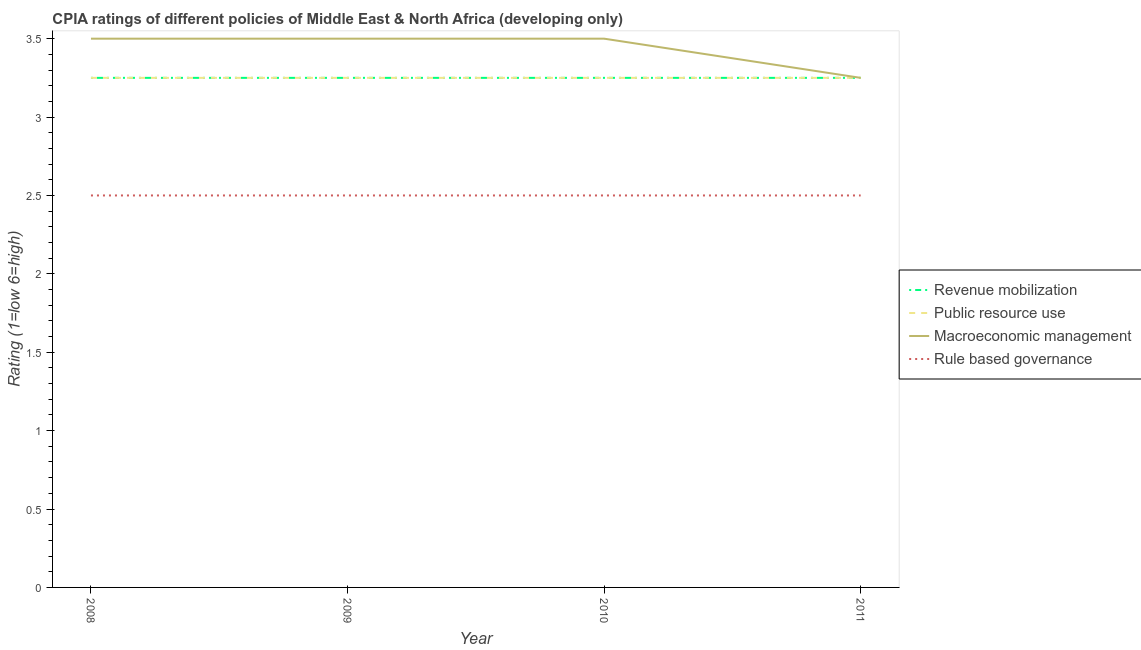What is the cpia rating of public resource use in 2010?
Your answer should be very brief. 3.25. Across all years, what is the maximum cpia rating of macroeconomic management?
Give a very brief answer. 3.5. In which year was the cpia rating of macroeconomic management minimum?
Offer a very short reply. 2011. What is the total cpia rating of public resource use in the graph?
Your response must be concise. 13. What is the difference between the cpia rating of public resource use in 2008 and that in 2009?
Give a very brief answer. 0. What is the average cpia rating of public resource use per year?
Keep it short and to the point. 3.25. In how many years, is the cpia rating of revenue mobilization greater than 1.4?
Keep it short and to the point. 4. What is the ratio of the cpia rating of public resource use in 2010 to that in 2011?
Keep it short and to the point. 1. Is the cpia rating of revenue mobilization in 2010 less than that in 2011?
Give a very brief answer. No. Is the difference between the cpia rating of rule based governance in 2008 and 2011 greater than the difference between the cpia rating of revenue mobilization in 2008 and 2011?
Keep it short and to the point. No. In how many years, is the cpia rating of revenue mobilization greater than the average cpia rating of revenue mobilization taken over all years?
Make the answer very short. 0. Is the cpia rating of rule based governance strictly greater than the cpia rating of revenue mobilization over the years?
Make the answer very short. No. How many lines are there?
Keep it short and to the point. 4. Does the graph contain grids?
Your response must be concise. No. Where does the legend appear in the graph?
Ensure brevity in your answer.  Center right. What is the title of the graph?
Your answer should be very brief. CPIA ratings of different policies of Middle East & North Africa (developing only). Does "UNAIDS" appear as one of the legend labels in the graph?
Offer a terse response. No. What is the Rating (1=low 6=high) of Revenue mobilization in 2008?
Keep it short and to the point. 3.25. What is the Rating (1=low 6=high) in Revenue mobilization in 2009?
Make the answer very short. 3.25. What is the Rating (1=low 6=high) in Public resource use in 2009?
Provide a succinct answer. 3.25. What is the Rating (1=low 6=high) in Macroeconomic management in 2009?
Provide a short and direct response. 3.5. What is the Rating (1=low 6=high) in Rule based governance in 2009?
Your answer should be compact. 2.5. What is the Rating (1=low 6=high) of Public resource use in 2010?
Your answer should be very brief. 3.25. What is the Rating (1=low 6=high) of Macroeconomic management in 2010?
Your answer should be very brief. 3.5. What is the Rating (1=low 6=high) in Rule based governance in 2010?
Provide a short and direct response. 2.5. What is the Rating (1=low 6=high) in Revenue mobilization in 2011?
Provide a short and direct response. 3.25. What is the Rating (1=low 6=high) in Macroeconomic management in 2011?
Offer a very short reply. 3.25. Across all years, what is the maximum Rating (1=low 6=high) in Macroeconomic management?
Offer a terse response. 3.5. Across all years, what is the maximum Rating (1=low 6=high) of Rule based governance?
Offer a very short reply. 2.5. Across all years, what is the minimum Rating (1=low 6=high) of Revenue mobilization?
Offer a terse response. 3.25. Across all years, what is the minimum Rating (1=low 6=high) of Macroeconomic management?
Offer a very short reply. 3.25. Across all years, what is the minimum Rating (1=low 6=high) in Rule based governance?
Your response must be concise. 2.5. What is the total Rating (1=low 6=high) of Revenue mobilization in the graph?
Offer a very short reply. 13. What is the total Rating (1=low 6=high) in Macroeconomic management in the graph?
Your answer should be compact. 13.75. What is the total Rating (1=low 6=high) in Rule based governance in the graph?
Ensure brevity in your answer.  10. What is the difference between the Rating (1=low 6=high) of Revenue mobilization in 2008 and that in 2009?
Provide a succinct answer. 0. What is the difference between the Rating (1=low 6=high) in Macroeconomic management in 2008 and that in 2010?
Offer a terse response. 0. What is the difference between the Rating (1=low 6=high) of Public resource use in 2008 and that in 2011?
Provide a succinct answer. 0. What is the difference between the Rating (1=low 6=high) of Rule based governance in 2008 and that in 2011?
Offer a terse response. 0. What is the difference between the Rating (1=low 6=high) of Rule based governance in 2009 and that in 2010?
Offer a very short reply. 0. What is the difference between the Rating (1=low 6=high) in Macroeconomic management in 2009 and that in 2011?
Your answer should be very brief. 0.25. What is the difference between the Rating (1=low 6=high) in Rule based governance in 2009 and that in 2011?
Offer a very short reply. 0. What is the difference between the Rating (1=low 6=high) of Revenue mobilization in 2010 and that in 2011?
Provide a short and direct response. 0. What is the difference between the Rating (1=low 6=high) of Macroeconomic management in 2010 and that in 2011?
Your answer should be compact. 0.25. What is the difference between the Rating (1=low 6=high) of Revenue mobilization in 2008 and the Rating (1=low 6=high) of Public resource use in 2009?
Provide a short and direct response. 0. What is the difference between the Rating (1=low 6=high) in Public resource use in 2008 and the Rating (1=low 6=high) in Macroeconomic management in 2009?
Keep it short and to the point. -0.25. What is the difference between the Rating (1=low 6=high) in Revenue mobilization in 2008 and the Rating (1=low 6=high) in Public resource use in 2010?
Give a very brief answer. 0. What is the difference between the Rating (1=low 6=high) of Public resource use in 2008 and the Rating (1=low 6=high) of Macroeconomic management in 2010?
Ensure brevity in your answer.  -0.25. What is the difference between the Rating (1=low 6=high) in Public resource use in 2008 and the Rating (1=low 6=high) in Rule based governance in 2010?
Make the answer very short. 0.75. What is the difference between the Rating (1=low 6=high) in Macroeconomic management in 2008 and the Rating (1=low 6=high) in Rule based governance in 2010?
Provide a short and direct response. 1. What is the difference between the Rating (1=low 6=high) of Revenue mobilization in 2008 and the Rating (1=low 6=high) of Macroeconomic management in 2011?
Keep it short and to the point. 0. What is the difference between the Rating (1=low 6=high) of Public resource use in 2008 and the Rating (1=low 6=high) of Macroeconomic management in 2011?
Provide a succinct answer. 0. What is the difference between the Rating (1=low 6=high) in Public resource use in 2008 and the Rating (1=low 6=high) in Rule based governance in 2011?
Your answer should be compact. 0.75. What is the difference between the Rating (1=low 6=high) in Revenue mobilization in 2009 and the Rating (1=low 6=high) in Public resource use in 2010?
Provide a succinct answer. 0. What is the difference between the Rating (1=low 6=high) of Public resource use in 2009 and the Rating (1=low 6=high) of Rule based governance in 2010?
Offer a terse response. 0.75. What is the difference between the Rating (1=low 6=high) of Macroeconomic management in 2009 and the Rating (1=low 6=high) of Rule based governance in 2010?
Provide a succinct answer. 1. What is the difference between the Rating (1=low 6=high) in Revenue mobilization in 2009 and the Rating (1=low 6=high) in Rule based governance in 2011?
Make the answer very short. 0.75. What is the difference between the Rating (1=low 6=high) of Public resource use in 2009 and the Rating (1=low 6=high) of Macroeconomic management in 2011?
Keep it short and to the point. 0. What is the difference between the Rating (1=low 6=high) of Public resource use in 2009 and the Rating (1=low 6=high) of Rule based governance in 2011?
Offer a very short reply. 0.75. What is the difference between the Rating (1=low 6=high) in Revenue mobilization in 2010 and the Rating (1=low 6=high) in Macroeconomic management in 2011?
Offer a very short reply. 0. What is the difference between the Rating (1=low 6=high) in Public resource use in 2010 and the Rating (1=low 6=high) in Macroeconomic management in 2011?
Ensure brevity in your answer.  0. What is the difference between the Rating (1=low 6=high) in Macroeconomic management in 2010 and the Rating (1=low 6=high) in Rule based governance in 2011?
Ensure brevity in your answer.  1. What is the average Rating (1=low 6=high) in Revenue mobilization per year?
Ensure brevity in your answer.  3.25. What is the average Rating (1=low 6=high) of Macroeconomic management per year?
Offer a very short reply. 3.44. In the year 2008, what is the difference between the Rating (1=low 6=high) of Revenue mobilization and Rating (1=low 6=high) of Rule based governance?
Your answer should be very brief. 0.75. In the year 2008, what is the difference between the Rating (1=low 6=high) in Public resource use and Rating (1=low 6=high) in Macroeconomic management?
Provide a succinct answer. -0.25. In the year 2008, what is the difference between the Rating (1=low 6=high) of Public resource use and Rating (1=low 6=high) of Rule based governance?
Give a very brief answer. 0.75. In the year 2009, what is the difference between the Rating (1=low 6=high) in Revenue mobilization and Rating (1=low 6=high) in Macroeconomic management?
Offer a terse response. -0.25. In the year 2009, what is the difference between the Rating (1=low 6=high) of Macroeconomic management and Rating (1=low 6=high) of Rule based governance?
Provide a succinct answer. 1. In the year 2010, what is the difference between the Rating (1=low 6=high) of Revenue mobilization and Rating (1=low 6=high) of Public resource use?
Make the answer very short. 0. In the year 2010, what is the difference between the Rating (1=low 6=high) in Revenue mobilization and Rating (1=low 6=high) in Macroeconomic management?
Provide a succinct answer. -0.25. In the year 2010, what is the difference between the Rating (1=low 6=high) of Revenue mobilization and Rating (1=low 6=high) of Rule based governance?
Provide a succinct answer. 0.75. In the year 2010, what is the difference between the Rating (1=low 6=high) of Public resource use and Rating (1=low 6=high) of Macroeconomic management?
Offer a terse response. -0.25. In the year 2010, what is the difference between the Rating (1=low 6=high) of Public resource use and Rating (1=low 6=high) of Rule based governance?
Provide a succinct answer. 0.75. In the year 2011, what is the difference between the Rating (1=low 6=high) of Revenue mobilization and Rating (1=low 6=high) of Public resource use?
Keep it short and to the point. 0. In the year 2011, what is the difference between the Rating (1=low 6=high) in Revenue mobilization and Rating (1=low 6=high) in Macroeconomic management?
Ensure brevity in your answer.  0. In the year 2011, what is the difference between the Rating (1=low 6=high) in Revenue mobilization and Rating (1=low 6=high) in Rule based governance?
Make the answer very short. 0.75. What is the ratio of the Rating (1=low 6=high) of Public resource use in 2008 to that in 2009?
Give a very brief answer. 1. What is the ratio of the Rating (1=low 6=high) of Macroeconomic management in 2008 to that in 2009?
Provide a short and direct response. 1. What is the ratio of the Rating (1=low 6=high) in Revenue mobilization in 2008 to that in 2010?
Your answer should be very brief. 1. What is the ratio of the Rating (1=low 6=high) in Public resource use in 2008 to that in 2010?
Your response must be concise. 1. What is the ratio of the Rating (1=low 6=high) of Macroeconomic management in 2008 to that in 2010?
Give a very brief answer. 1. What is the ratio of the Rating (1=low 6=high) of Rule based governance in 2008 to that in 2010?
Your answer should be compact. 1. What is the ratio of the Rating (1=low 6=high) of Macroeconomic management in 2008 to that in 2011?
Offer a very short reply. 1.08. What is the ratio of the Rating (1=low 6=high) of Macroeconomic management in 2009 to that in 2010?
Provide a succinct answer. 1. What is the ratio of the Rating (1=low 6=high) in Rule based governance in 2009 to that in 2010?
Provide a succinct answer. 1. What is the ratio of the Rating (1=low 6=high) in Public resource use in 2009 to that in 2011?
Offer a very short reply. 1. What is the ratio of the Rating (1=low 6=high) in Rule based governance in 2009 to that in 2011?
Keep it short and to the point. 1. What is the ratio of the Rating (1=low 6=high) in Macroeconomic management in 2010 to that in 2011?
Ensure brevity in your answer.  1.08. What is the ratio of the Rating (1=low 6=high) in Rule based governance in 2010 to that in 2011?
Keep it short and to the point. 1. What is the difference between the highest and the second highest Rating (1=low 6=high) of Revenue mobilization?
Ensure brevity in your answer.  0. What is the difference between the highest and the second highest Rating (1=low 6=high) in Public resource use?
Ensure brevity in your answer.  0. What is the difference between the highest and the lowest Rating (1=low 6=high) in Revenue mobilization?
Provide a succinct answer. 0. What is the difference between the highest and the lowest Rating (1=low 6=high) of Public resource use?
Offer a terse response. 0. What is the difference between the highest and the lowest Rating (1=low 6=high) of Macroeconomic management?
Provide a succinct answer. 0.25. What is the difference between the highest and the lowest Rating (1=low 6=high) in Rule based governance?
Provide a short and direct response. 0. 